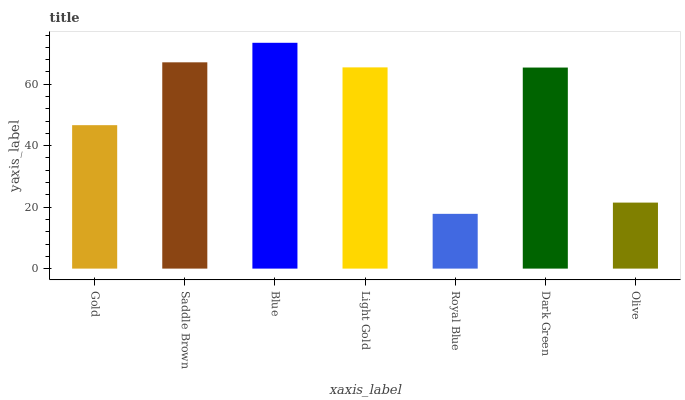Is Royal Blue the minimum?
Answer yes or no. Yes. Is Blue the maximum?
Answer yes or no. Yes. Is Saddle Brown the minimum?
Answer yes or no. No. Is Saddle Brown the maximum?
Answer yes or no. No. Is Saddle Brown greater than Gold?
Answer yes or no. Yes. Is Gold less than Saddle Brown?
Answer yes or no. Yes. Is Gold greater than Saddle Brown?
Answer yes or no. No. Is Saddle Brown less than Gold?
Answer yes or no. No. Is Dark Green the high median?
Answer yes or no. Yes. Is Dark Green the low median?
Answer yes or no. Yes. Is Light Gold the high median?
Answer yes or no. No. Is Royal Blue the low median?
Answer yes or no. No. 